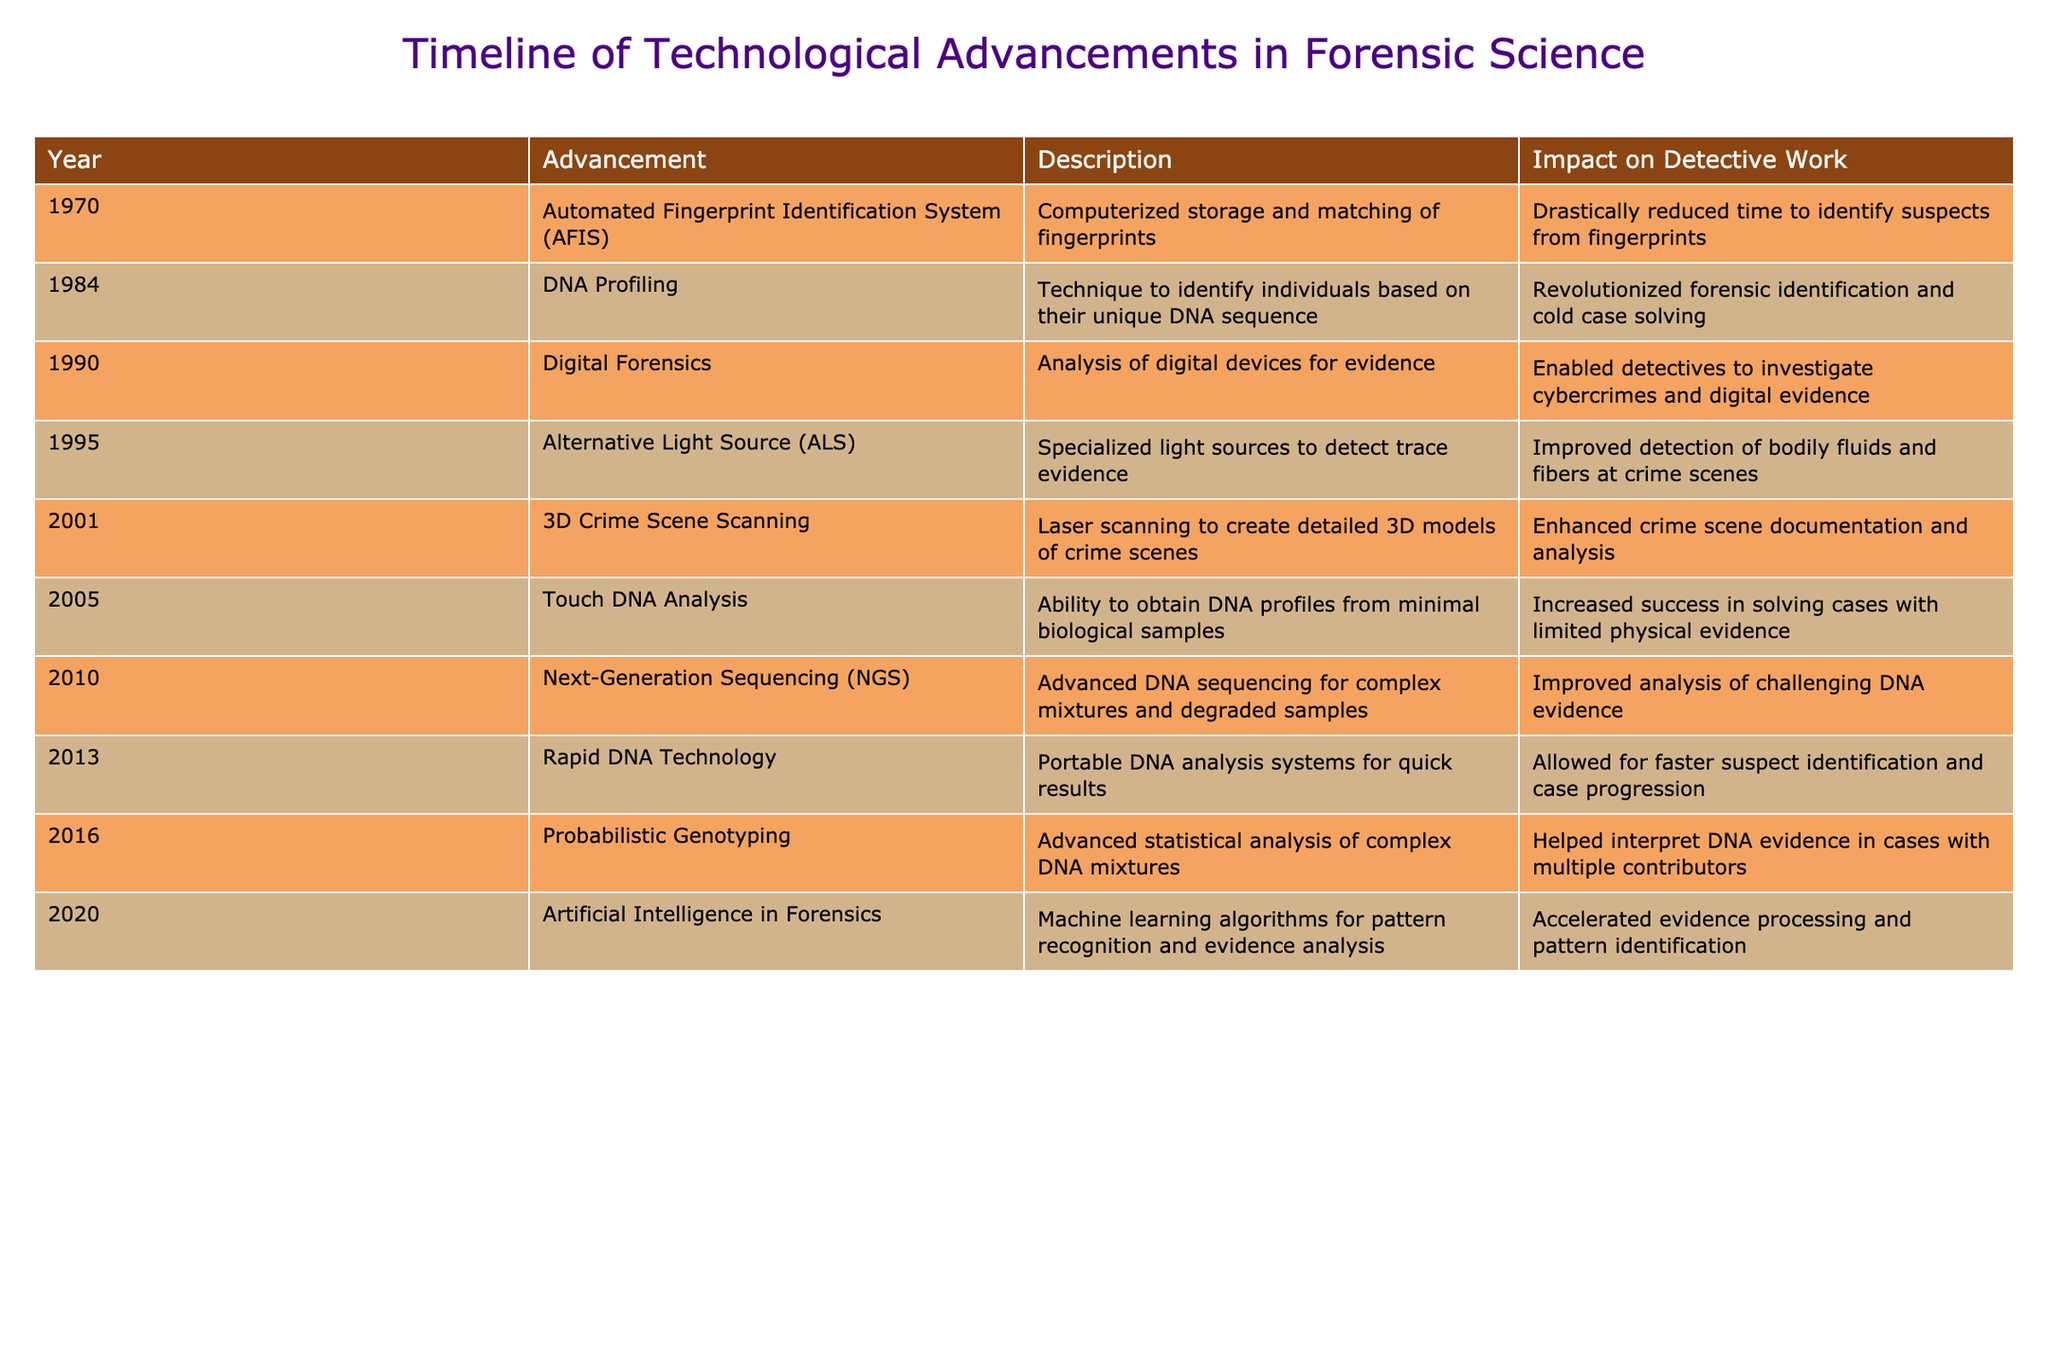What year was the Automated Fingerprint Identification System introduced? The table indicates that the Automated Fingerprint Identification System was introduced in 1970. By simply locating the corresponding row for this advancement, the answer is found.
Answer: 1970 How many advancements in forensic technology occurred before 2000? Counting the entries in the table from the earliest year (1970) to just before 2000, there are a total of 5 advancements listed in this period (1970, 1984, 1990, 1995).
Answer: 5 Did the introduction of DNA Profiling revolutionize forensic identification? According to the description in the table for DNA Profiling, it states that this technique revolutionized forensic identification, confirming the fact as true.
Answer: Yes What is the impact of Rapid DNA Technology on suspect identification? The table explains that Rapid DNA Technology allowed for faster suspect identification and case progression. Thus, it can be concluded that its impact was significant in speeding up the investigation process.
Answer: Faster suspect identification Which technological advancement allowed for 3D documentation of crime scenes? The table states that 3D Crime Scene Scanning, introduced in 2001, is responsible for creating detailed 3D models of crime scenes. Thus, this is the advancement that enabled 3D documentation.
Answer: 3D Crime Scene Scanning Calculate the difference in years between the introduction of Touch DNA Analysis and Next-Generation Sequencing. Touch DNA Analysis was introduced in 2005 and Next-Generation Sequencing in 2010. The difference is calculated by subtracting the earlier year from the later one (2010 - 2005 = 5). Therefore, the difference is 5 years.
Answer: 5 years Since 2010, how many advancements have focused on DNA-related technologies? By reviewing the table rows from 2010 onwards, we identify three advancements related to DNA: Touch DNA Analysis (2005), Next-Generation Sequencing (2010), and Rapid DNA Technology (2013), plus Probabilistic Genotyping (2016). Therefore, there are four advancements focusing on DNA technology.
Answer: 4 What was the effect of Artificial Intelligence in Forensics according to the table? The table states that Artificial Intelligence in Forensics accelerated evidence processing and pattern identification. This suggests a substantial enhancement in efficiency and analysis capabilities for detectives.
Answer: Accelerated evidence processing If a detective is investigating a case from 1995, which forensic technology would they primarily rely on? From the table, the last advancement in 1995 was the Alternative Light Source (ALS). Therefore, if investigating a case from that year, the detective would primarily rely on this specific technology for evidence detection.
Answer: Alternative Light Source (ALS) 